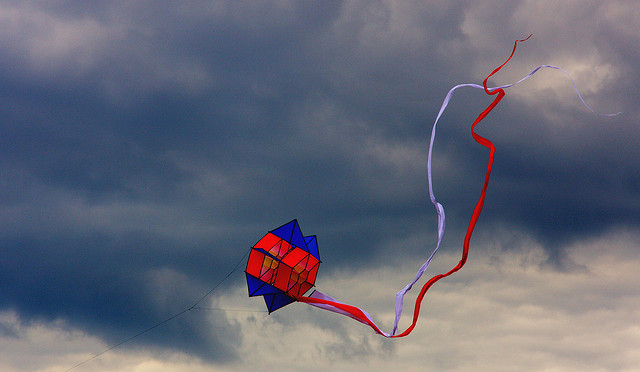Describe the atmosphere of the scene and what it suggests about the upcoming weather. The scene features a sky dominated by dark, tumultuous clouds, indicating an overcast atmosphere. The dense cloud cover hints at the possibility of an impending storm or rain. Despite the overcast conditions, the vibrant kite adds a splash of color and energy to the landscape. The overall atmosphere combines a sense of tension and beauty, as the colorful kite contrasts with the moody sky, suggesting a moment of calm before the storm. If you were standing there, what sounds and sensations might you experience? Standing there, you would likely hear the rustle of the wind as it sweeps past, causing the kite tails to flutter and snap sharply. The sky, heavy with clouds, would create a muted ambiance, with occasional gusts of wind adding layers of sound. You might feel the cool breeze against your skin, invigorating yet slightly chilling due to the overcast conditions. The taut string of the kite, buzzing with tension, transfers the kite's dance in the air to your hand, creating an intimate sensory connection to the flight. Can you write a poetic description of the image? Beneath a sky of tempest-gray, a vibrant kite ignites the day. Its colors bloom in spirited flight, a beacon against the fading light. Long tails of red and white, entwined, weave stories in the restless wind's refined. The heavens churn in brooding grace, while the kite ascends to find its space. In this ballet of storm and hue, where freedom dances in skies of blue, the heart finds solace, bold and free, in the kite's wild, soaring spree. 